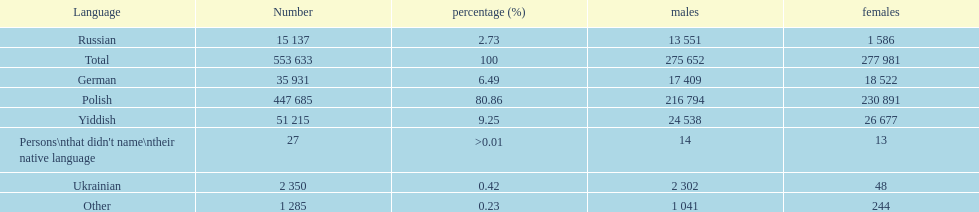Which is the least spoken language? Ukrainian. 